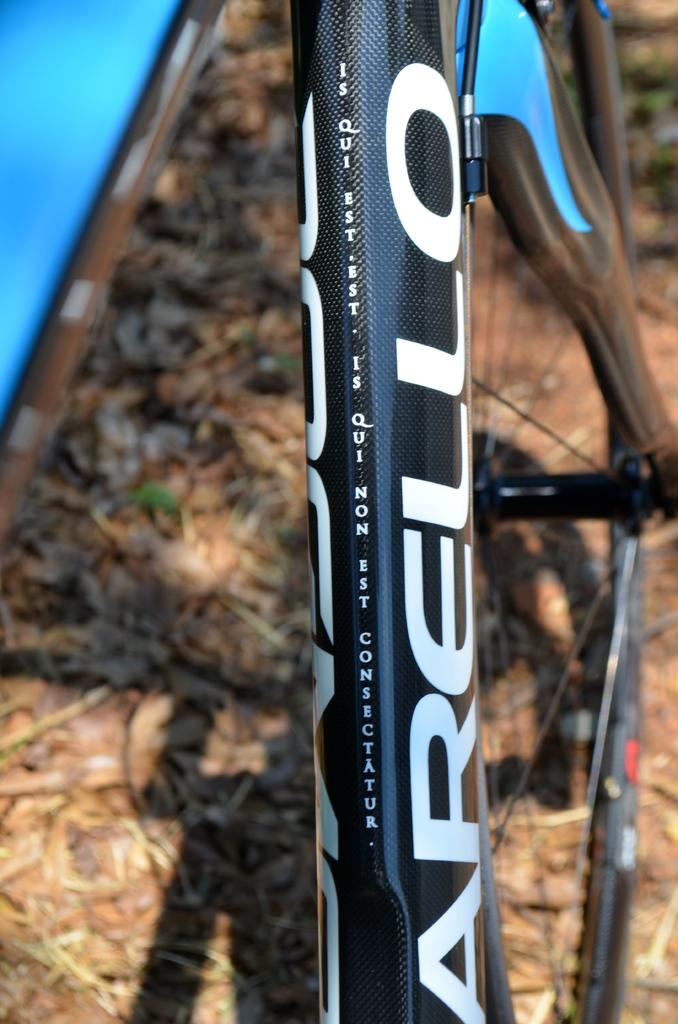What can be seen in the image that is related to a cycle? There is a cycle rod in the image. Is there any text or writing on the cycle rod? Yes, something is written on the cycle rod. What type of terrain is visible at the bottom of the image? There is grass on the ground at the bottom of the image. What type of space vehicle can be seen in the image? There is no space vehicle present in the image; it features a cycle rod and grass. What type of authority figure is depicted in the image? There is no authority figure present in the image; it features a cycle rod and grass. 